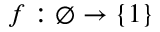Convert formula to latex. <formula><loc_0><loc_0><loc_500><loc_500>f \colon \emptyset \to \{ 1 \}</formula> 